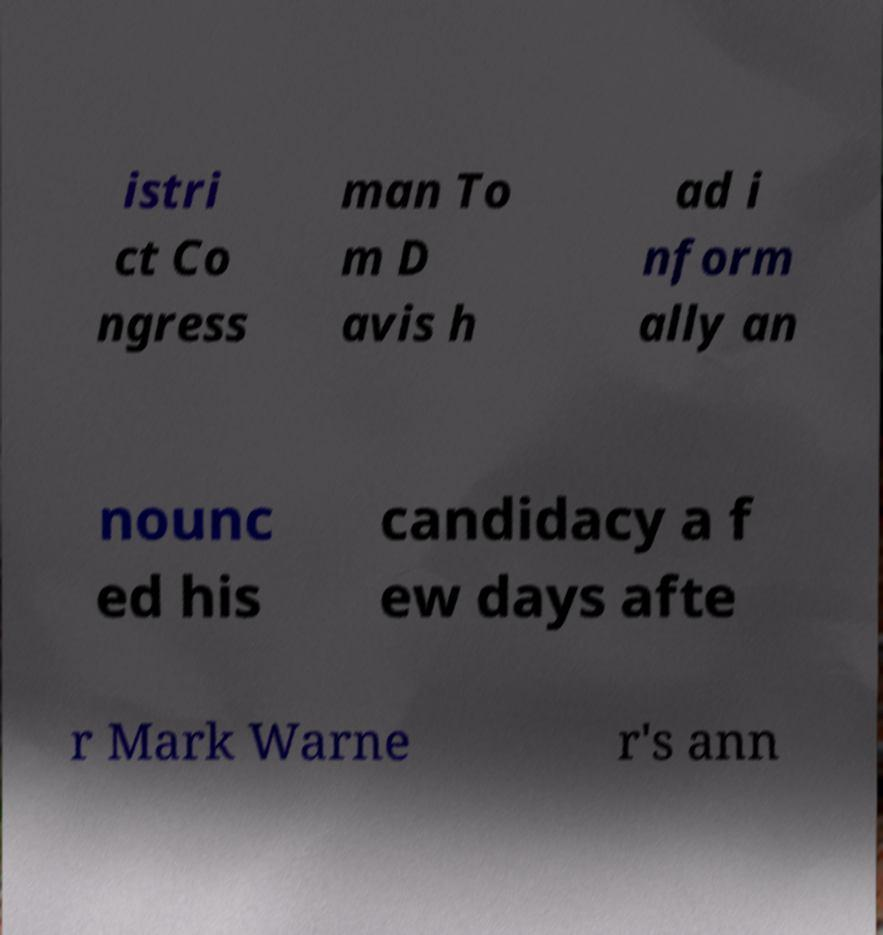Please read and relay the text visible in this image. What does it say? istri ct Co ngress man To m D avis h ad i nform ally an nounc ed his candidacy a f ew days afte r Mark Warne r's ann 